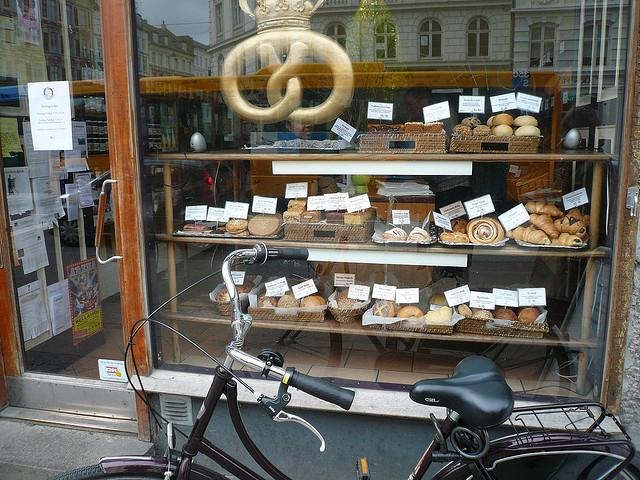What color is painted on the metal frame of the bicycle parked in front of the cake store? black 